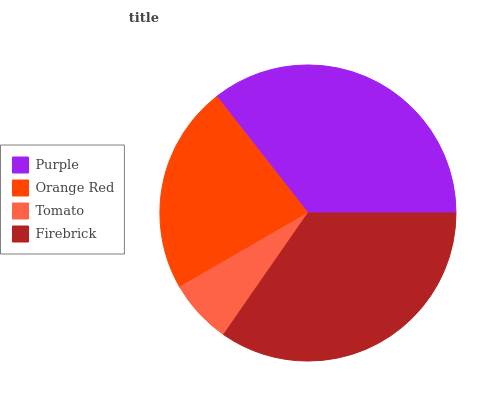Is Tomato the minimum?
Answer yes or no. Yes. Is Purple the maximum?
Answer yes or no. Yes. Is Orange Red the minimum?
Answer yes or no. No. Is Orange Red the maximum?
Answer yes or no. No. Is Purple greater than Orange Red?
Answer yes or no. Yes. Is Orange Red less than Purple?
Answer yes or no. Yes. Is Orange Red greater than Purple?
Answer yes or no. No. Is Purple less than Orange Red?
Answer yes or no. No. Is Firebrick the high median?
Answer yes or no. Yes. Is Orange Red the low median?
Answer yes or no. Yes. Is Purple the high median?
Answer yes or no. No. Is Purple the low median?
Answer yes or no. No. 